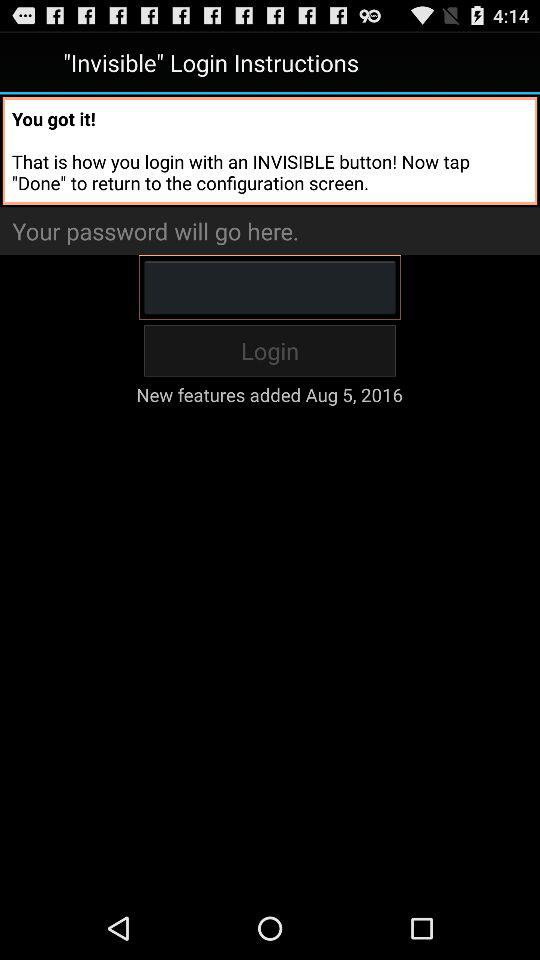When were the new features added? The new features were added on August 5, 2016. 